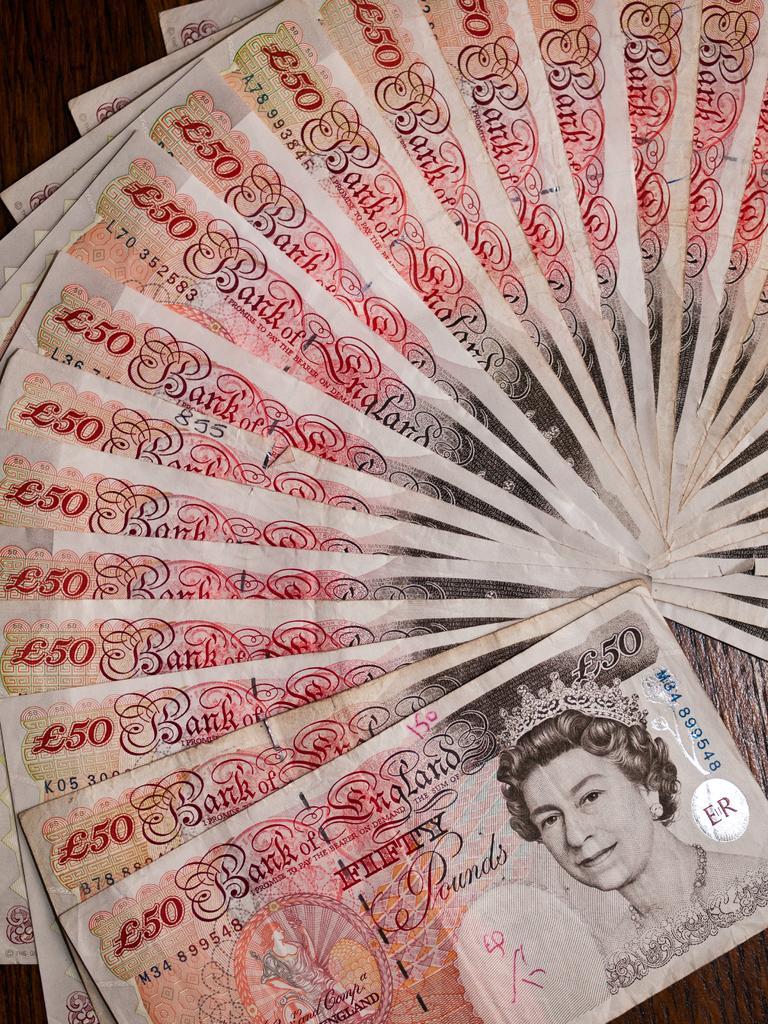Describe this image in one or two sentences. These are the banknotes of the pound sterling. I can see the picture of a woman with a crown on a banknote. 